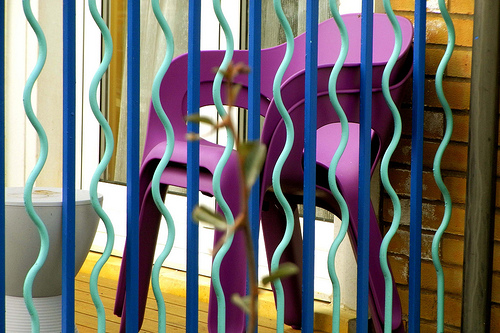<image>
Can you confirm if the chair is in front of the wall? Yes. The chair is positioned in front of the wall, appearing closer to the camera viewpoint. 